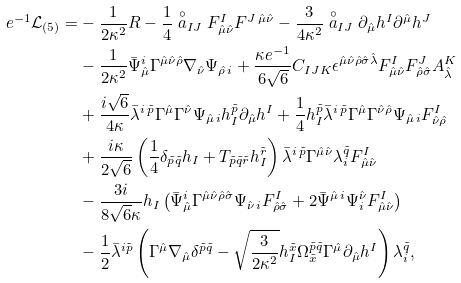Convert formula to latex. <formula><loc_0><loc_0><loc_500><loc_500>e ^ { - 1 } \mathcal { L } _ { ( 5 ) } = & - \frac { 1 } { 2 \kappa ^ { 2 } } R - \frac { 1 } { 4 } \stackrel { \circ } { a } _ { I J } F ^ { I } _ { \hat { \mu } \hat { \nu } } F ^ { J \, \hat { \mu } \hat { \nu } } - \frac { 3 } { 4 \kappa ^ { 2 } } \stackrel { \circ } { a } _ { I J } \partial _ { \hat { \mu } } h ^ { I } \partial ^ { \hat { \mu } } h ^ { J } \\ & - \frac { 1 } { 2 \kappa ^ { 2 } } \bar { \Psi } ^ { i } _ { \hat { \mu } } \Gamma ^ { \hat { \mu } \hat { \nu } \hat { \rho } } \nabla _ { \hat { \nu } } \Psi _ { \hat { \rho } \, i } + \frac { \kappa e ^ { - 1 } } { 6 \sqrt { 6 } } C _ { I J K } \epsilon ^ { \hat { \mu } \hat { \nu } \hat { \rho } \hat { \sigma } \hat { \lambda } } F ^ { I } _ { \hat { \mu } \hat { \nu } } F ^ { J } _ { \hat { \rho } \hat { \sigma } } A ^ { K } _ { \hat { \lambda } } \\ & + \frac { i \sqrt { 6 } } { 4 \kappa } \bar { \lambda } ^ { i \, \tilde { p } } \Gamma ^ { \hat { \mu } } \Gamma ^ { \hat { \nu } } \Psi _ { \hat { \mu } \, i } h ^ { \tilde { p } } _ { I } \partial _ { \hat { \mu } } h ^ { I } + \frac { 1 } { 4 } h ^ { \tilde { p } } _ { I } \bar { \lambda } ^ { i \, \tilde { p } } \Gamma ^ { \hat { \mu } } \Gamma ^ { \hat { \nu } \hat { \rho } } \Psi _ { \hat { \mu } \, i } F ^ { I } _ { \hat { \nu } \hat { \rho } } \\ & + \frac { i \kappa } { 2 \sqrt { 6 } } \left ( \frac { 1 } { 4 } \delta _ { \tilde { p } \tilde { q } } h _ { I } + T _ { \tilde { p } \tilde { q } \tilde { r } } h ^ { \tilde { r } } _ { I } \right ) \bar { \lambda } ^ { i \, \tilde { p } } \Gamma ^ { \hat { \mu } \hat { \nu } } \lambda ^ { \tilde { q } } _ { i } F ^ { I } _ { \hat { \mu } \hat { \nu } } \\ & - \frac { 3 i } { 8 \sqrt { 6 } \kappa } h _ { I } \left ( \bar { \Psi } ^ { i } _ { \hat { \mu } } \Gamma ^ { \hat { \mu } \hat { \nu } \hat { \rho } \hat { \sigma } } \Psi _ { \hat { \nu } \, i } F ^ { I } _ { \hat { \rho } \hat { \sigma } } + 2 \bar { \Psi } ^ { \hat { \mu } \, i } \Psi ^ { \hat { \nu } } _ { i } F ^ { I } _ { \hat { \mu } \hat { \nu } } \right ) \\ & - \frac { 1 } { 2 } \bar { \lambda } ^ { i \tilde { p } } \left ( \Gamma ^ { \hat { \mu } } \nabla _ { \hat { \mu } } \delta ^ { \tilde { p } \tilde { q } } - \sqrt { \frac { 3 } { 2 \kappa ^ { 2 } } } h ^ { \tilde { x } } _ { I } \Omega ^ { \tilde { p } \tilde { q } } _ { \tilde { x } } \Gamma ^ { \hat { \mu } } \partial _ { \hat { \mu } } h ^ { I } \right ) \lambda ^ { \tilde { q } } _ { i } ,</formula> 